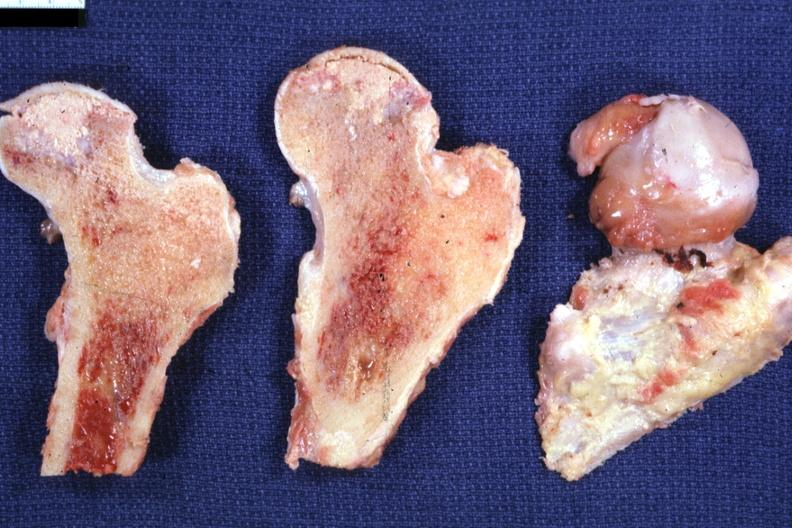what does this image show?
Answer the question using a single word or phrase. Sectioned femoral heads showing very nicely necrosis excellent 